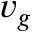Convert formula to latex. <formula><loc_0><loc_0><loc_500><loc_500>v _ { g }</formula> 